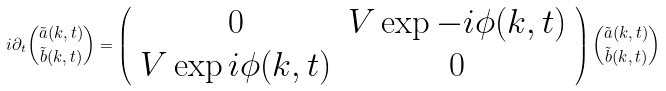Convert formula to latex. <formula><loc_0><loc_0><loc_500><loc_500>i \partial _ { t } \binom { \tilde { a } ( k , t ) } { \tilde { b } ( k , t ) } = \left ( \begin{array} { c c } 0 & V \exp { - i \phi ( k , t ) } \\ V \exp { i \phi ( k , t ) } & 0 \end{array} \right ) \binom { \tilde { a } ( k , t ) } { \tilde { b } ( k , t ) }</formula> 